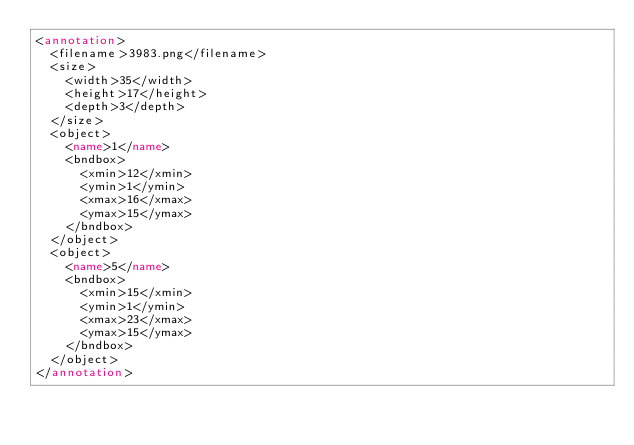<code> <loc_0><loc_0><loc_500><loc_500><_XML_><annotation>
  <filename>3983.png</filename>
  <size>
    <width>35</width>
    <height>17</height>
    <depth>3</depth>
  </size>
  <object>
    <name>1</name>
    <bndbox>
      <xmin>12</xmin>
      <ymin>1</ymin>
      <xmax>16</xmax>
      <ymax>15</ymax>
    </bndbox>
  </object>
  <object>
    <name>5</name>
    <bndbox>
      <xmin>15</xmin>
      <ymin>1</ymin>
      <xmax>23</xmax>
      <ymax>15</ymax>
    </bndbox>
  </object>
</annotation>
</code> 